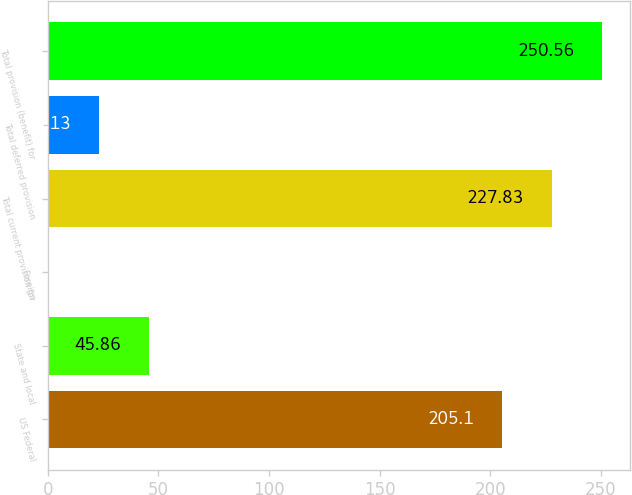<chart> <loc_0><loc_0><loc_500><loc_500><bar_chart><fcel>US Federal<fcel>State and local<fcel>Foreign<fcel>Total current provision for<fcel>Total deferred provision<fcel>Total provision (benefit) for<nl><fcel>205.1<fcel>45.86<fcel>0.4<fcel>227.83<fcel>23.13<fcel>250.56<nl></chart> 